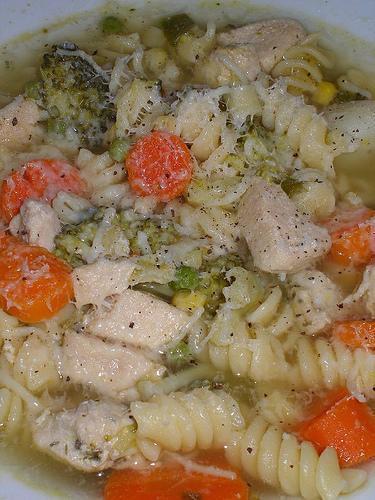How many carrots can you see?
Give a very brief answer. 6. 